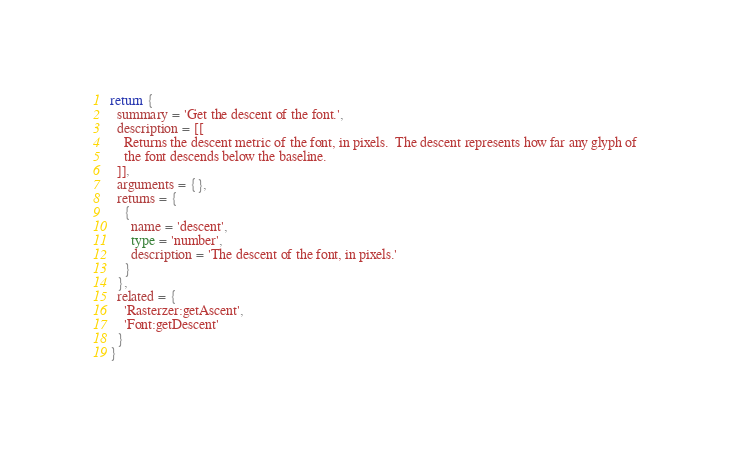Convert code to text. <code><loc_0><loc_0><loc_500><loc_500><_Lua_>return {
  summary = 'Get the descent of the font.',
  description = [[
    Returns the descent metric of the font, in pixels.  The descent represents how far any glyph of
    the font descends below the baseline.
  ]],
  arguments = {},
  returns = {
    {
      name = 'descent',
      type = 'number',
      description = 'The descent of the font, in pixels.'
    }
  },
  related = {
    'Rasterzer:getAscent',
    'Font:getDescent'
  }
}
</code> 